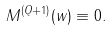Convert formula to latex. <formula><loc_0><loc_0><loc_500><loc_500>M ^ { ( Q + 1 ) } ( w ) \equiv 0 .</formula> 